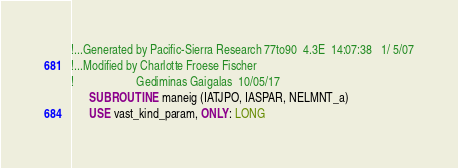<code> <loc_0><loc_0><loc_500><loc_500><_FORTRAN_>!...Generated by Pacific-Sierra Research 77to90  4.3E  14:07:38   1/ 5/07
!...Modified by Charlotte Froese Fischer
!                     Gediminas Gaigalas  10/05/17
      SUBROUTINE maneig (IATJPO, IASPAR, NELMNT_a)
      USE vast_kind_param, ONLY: LONG</code> 